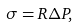<formula> <loc_0><loc_0><loc_500><loc_500>\sigma = R \Delta P ,</formula> 